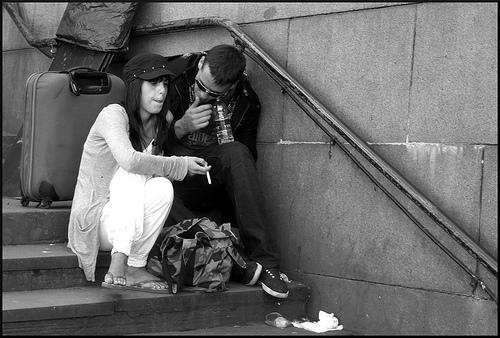For visual entailment, identify the correct statement regarding stairs. A rail leads up the stairs in the image. For multi-choice VQA, identify what the girl is doing with her right hand. The girl is holding a cigarette in her right hand. For product advertisement, describe the features of the suitcase in the image. The suitcase has a black handle, wheels, and is sitting on the landing of the staircase. 